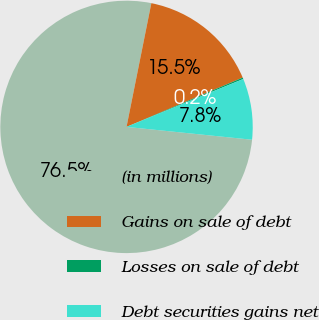Convert chart. <chart><loc_0><loc_0><loc_500><loc_500><pie_chart><fcel>(in millions)<fcel>Gains on sale of debt<fcel>Losses on sale of debt<fcel>Debt securities gains net<nl><fcel>76.53%<fcel>15.46%<fcel>0.19%<fcel>7.82%<nl></chart> 